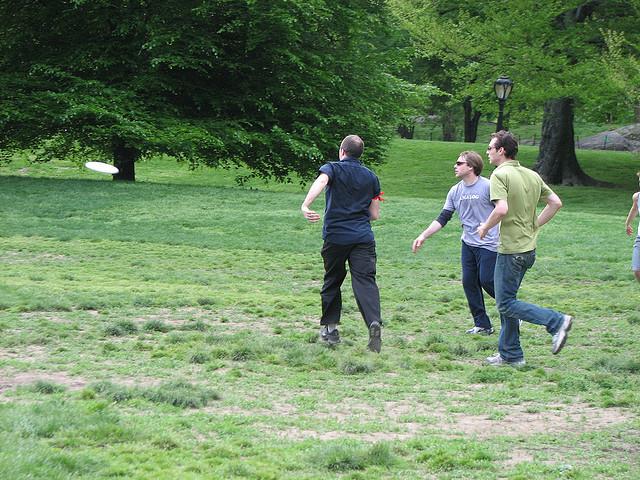Why are the men running?
Be succinct. Playing frisbee. What animal is in the air?
Give a very brief answer. None. Where are the men looking?
Write a very short answer. At frisbee. What are the people doing?
Be succinct. Playing frisbee. How many women are playing the game?
Concise answer only. 0. How many street lights are in the picture?
Keep it brief. 1. 